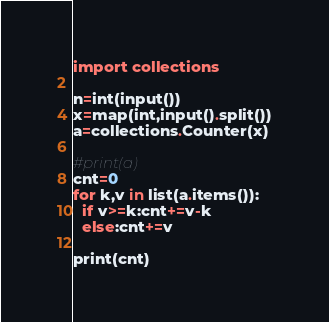Convert code to text. <code><loc_0><loc_0><loc_500><loc_500><_Python_>import collections

n=int(input())
x=map(int,input().split())
a=collections.Counter(x)

#print(a)
cnt=0
for k,v in list(a.items()):
  if v>=k:cnt+=v-k
  else:cnt+=v
    
print(cnt)</code> 